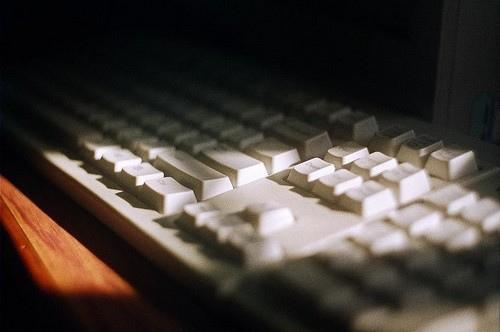How many keyboards are there?
Give a very brief answer. 1. How many keyboards are in the photo?
Give a very brief answer. 1. 